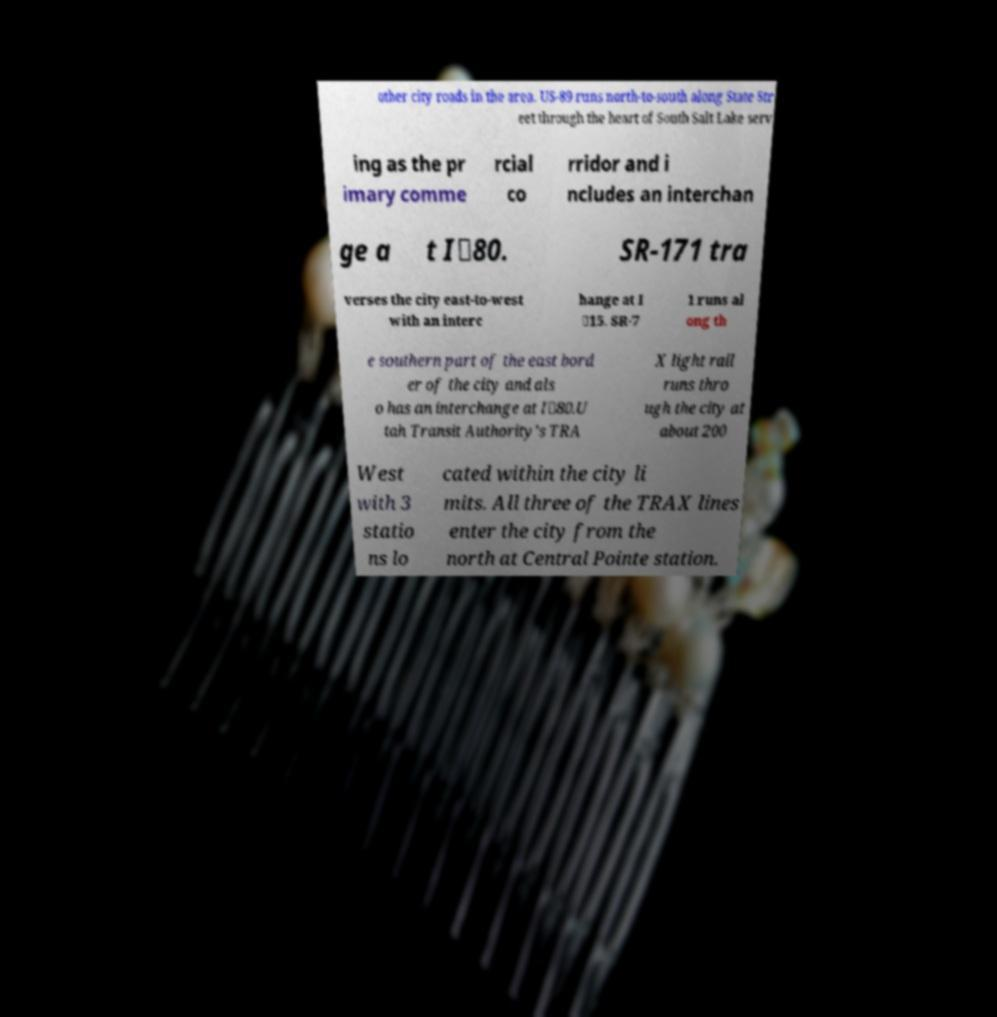Can you read and provide the text displayed in the image?This photo seems to have some interesting text. Can you extract and type it out for me? other city roads in the area. US-89 runs north-to-south along State Str eet through the heart of South Salt Lake serv ing as the pr imary comme rcial co rridor and i ncludes an interchan ge a t I‑80. SR-171 tra verses the city east-to-west with an interc hange at I ‑15. SR-7 1 runs al ong th e southern part of the east bord er of the city and als o has an interchange at I‑80.U tah Transit Authority's TRA X light rail runs thro ugh the city at about 200 West with 3 statio ns lo cated within the city li mits. All three of the TRAX lines enter the city from the north at Central Pointe station. 